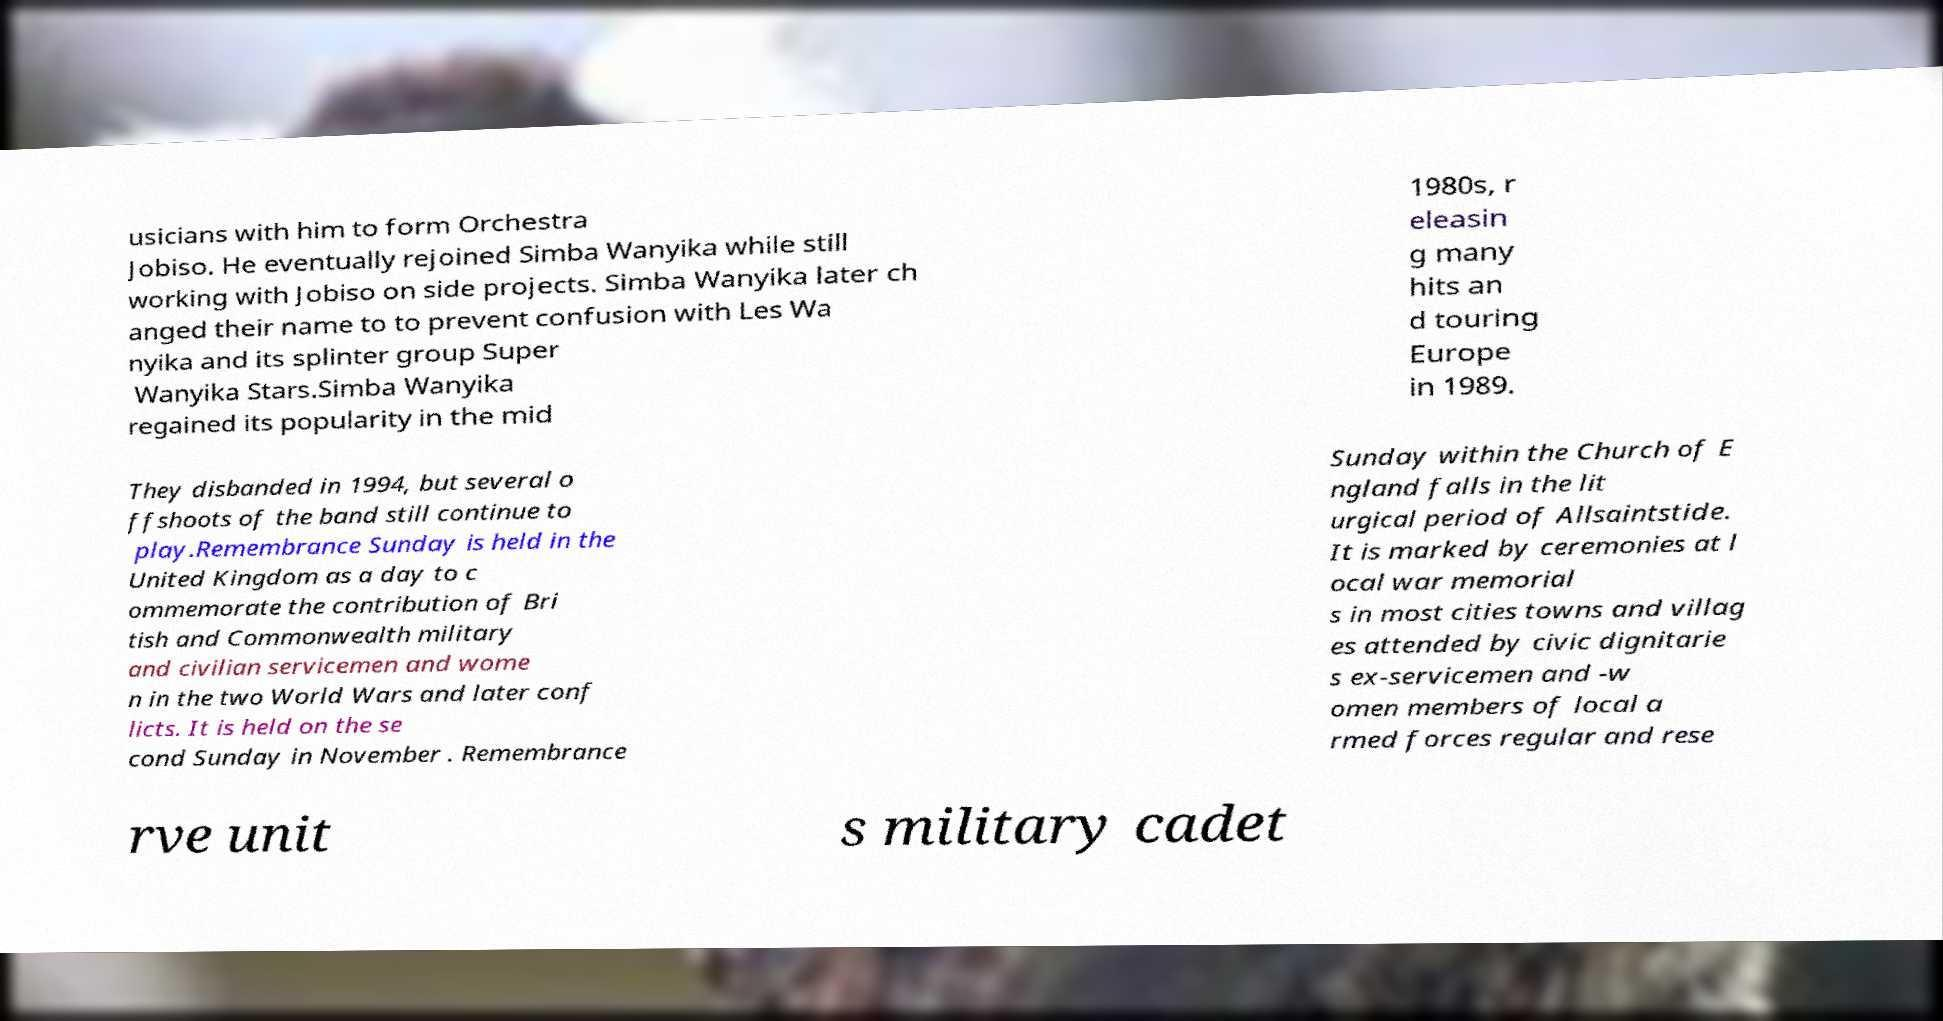Can you accurately transcribe the text from the provided image for me? usicians with him to form Orchestra Jobiso. He eventually rejoined Simba Wanyika while still working with Jobiso on side projects. Simba Wanyika later ch anged their name to to prevent confusion with Les Wa nyika and its splinter group Super Wanyika Stars.Simba Wanyika regained its popularity in the mid 1980s, r eleasin g many hits an d touring Europe in 1989. They disbanded in 1994, but several o ffshoots of the band still continue to play.Remembrance Sunday is held in the United Kingdom as a day to c ommemorate the contribution of Bri tish and Commonwealth military and civilian servicemen and wome n in the two World Wars and later conf licts. It is held on the se cond Sunday in November . Remembrance Sunday within the Church of E ngland falls in the lit urgical period of Allsaintstide. It is marked by ceremonies at l ocal war memorial s in most cities towns and villag es attended by civic dignitarie s ex-servicemen and -w omen members of local a rmed forces regular and rese rve unit s military cadet 